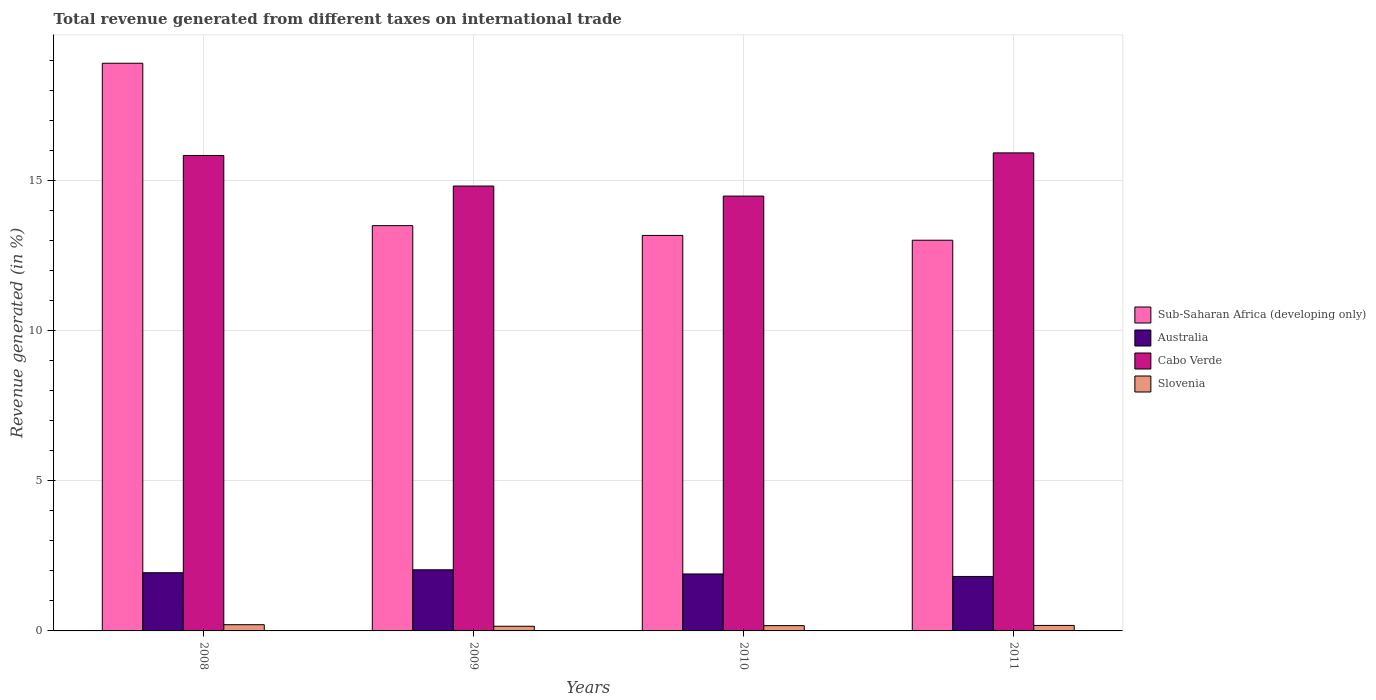Are the number of bars on each tick of the X-axis equal?
Your answer should be compact. Yes. How many bars are there on the 4th tick from the left?
Your answer should be very brief. 4. What is the label of the 4th group of bars from the left?
Ensure brevity in your answer.  2011. In how many cases, is the number of bars for a given year not equal to the number of legend labels?
Offer a very short reply. 0. What is the total revenue generated in Slovenia in 2008?
Offer a terse response. 0.21. Across all years, what is the maximum total revenue generated in Cabo Verde?
Your answer should be very brief. 15.92. Across all years, what is the minimum total revenue generated in Cabo Verde?
Offer a terse response. 14.48. In which year was the total revenue generated in Cabo Verde minimum?
Offer a terse response. 2010. What is the total total revenue generated in Sub-Saharan Africa (developing only) in the graph?
Make the answer very short. 58.58. What is the difference between the total revenue generated in Slovenia in 2009 and that in 2011?
Keep it short and to the point. -0.03. What is the difference between the total revenue generated in Cabo Verde in 2008 and the total revenue generated in Australia in 2010?
Offer a terse response. 13.94. What is the average total revenue generated in Slovenia per year?
Make the answer very short. 0.18. In the year 2011, what is the difference between the total revenue generated in Cabo Verde and total revenue generated in Australia?
Offer a terse response. 14.1. What is the ratio of the total revenue generated in Slovenia in 2010 to that in 2011?
Make the answer very short. 0.96. Is the difference between the total revenue generated in Cabo Verde in 2008 and 2009 greater than the difference between the total revenue generated in Australia in 2008 and 2009?
Provide a succinct answer. Yes. What is the difference between the highest and the second highest total revenue generated in Cabo Verde?
Keep it short and to the point. 0.09. What is the difference between the highest and the lowest total revenue generated in Australia?
Provide a succinct answer. 0.22. In how many years, is the total revenue generated in Slovenia greater than the average total revenue generated in Slovenia taken over all years?
Provide a succinct answer. 2. Is the sum of the total revenue generated in Sub-Saharan Africa (developing only) in 2009 and 2010 greater than the maximum total revenue generated in Australia across all years?
Offer a terse response. Yes. Is it the case that in every year, the sum of the total revenue generated in Sub-Saharan Africa (developing only) and total revenue generated in Cabo Verde is greater than the sum of total revenue generated in Australia and total revenue generated in Slovenia?
Offer a terse response. Yes. What does the 1st bar from the left in 2008 represents?
Offer a very short reply. Sub-Saharan Africa (developing only). What does the 1st bar from the right in 2009 represents?
Make the answer very short. Slovenia. Is it the case that in every year, the sum of the total revenue generated in Sub-Saharan Africa (developing only) and total revenue generated in Australia is greater than the total revenue generated in Cabo Verde?
Provide a succinct answer. No. How many bars are there?
Offer a terse response. 16. Are all the bars in the graph horizontal?
Provide a short and direct response. No. Does the graph contain any zero values?
Ensure brevity in your answer.  No. Does the graph contain grids?
Give a very brief answer. Yes. How many legend labels are there?
Offer a terse response. 4. What is the title of the graph?
Your answer should be compact. Total revenue generated from different taxes on international trade. Does "Upper middle income" appear as one of the legend labels in the graph?
Make the answer very short. No. What is the label or title of the Y-axis?
Make the answer very short. Revenue generated (in %). What is the Revenue generated (in %) in Sub-Saharan Africa (developing only) in 2008?
Make the answer very short. 18.9. What is the Revenue generated (in %) in Australia in 2008?
Keep it short and to the point. 1.94. What is the Revenue generated (in %) of Cabo Verde in 2008?
Provide a short and direct response. 15.83. What is the Revenue generated (in %) of Slovenia in 2008?
Your response must be concise. 0.21. What is the Revenue generated (in %) in Sub-Saharan Africa (developing only) in 2009?
Ensure brevity in your answer.  13.5. What is the Revenue generated (in %) of Australia in 2009?
Make the answer very short. 2.04. What is the Revenue generated (in %) in Cabo Verde in 2009?
Offer a terse response. 14.81. What is the Revenue generated (in %) of Slovenia in 2009?
Keep it short and to the point. 0.16. What is the Revenue generated (in %) in Sub-Saharan Africa (developing only) in 2010?
Keep it short and to the point. 13.17. What is the Revenue generated (in %) of Australia in 2010?
Offer a terse response. 1.9. What is the Revenue generated (in %) of Cabo Verde in 2010?
Ensure brevity in your answer.  14.48. What is the Revenue generated (in %) of Slovenia in 2010?
Offer a very short reply. 0.18. What is the Revenue generated (in %) in Sub-Saharan Africa (developing only) in 2011?
Offer a terse response. 13.01. What is the Revenue generated (in %) of Australia in 2011?
Your answer should be very brief. 1.81. What is the Revenue generated (in %) in Cabo Verde in 2011?
Make the answer very short. 15.92. What is the Revenue generated (in %) of Slovenia in 2011?
Your answer should be very brief. 0.18. Across all years, what is the maximum Revenue generated (in %) in Sub-Saharan Africa (developing only)?
Make the answer very short. 18.9. Across all years, what is the maximum Revenue generated (in %) in Australia?
Keep it short and to the point. 2.04. Across all years, what is the maximum Revenue generated (in %) in Cabo Verde?
Make the answer very short. 15.92. Across all years, what is the maximum Revenue generated (in %) in Slovenia?
Keep it short and to the point. 0.21. Across all years, what is the minimum Revenue generated (in %) in Sub-Saharan Africa (developing only)?
Your answer should be very brief. 13.01. Across all years, what is the minimum Revenue generated (in %) of Australia?
Provide a succinct answer. 1.81. Across all years, what is the minimum Revenue generated (in %) of Cabo Verde?
Give a very brief answer. 14.48. Across all years, what is the minimum Revenue generated (in %) in Slovenia?
Give a very brief answer. 0.16. What is the total Revenue generated (in %) in Sub-Saharan Africa (developing only) in the graph?
Keep it short and to the point. 58.58. What is the total Revenue generated (in %) in Australia in the graph?
Keep it short and to the point. 7.68. What is the total Revenue generated (in %) in Cabo Verde in the graph?
Make the answer very short. 61.05. What is the total Revenue generated (in %) in Slovenia in the graph?
Your answer should be compact. 0.72. What is the difference between the Revenue generated (in %) in Sub-Saharan Africa (developing only) in 2008 and that in 2009?
Keep it short and to the point. 5.41. What is the difference between the Revenue generated (in %) of Australia in 2008 and that in 2009?
Provide a short and direct response. -0.1. What is the difference between the Revenue generated (in %) in Cabo Verde in 2008 and that in 2009?
Your answer should be very brief. 1.02. What is the difference between the Revenue generated (in %) of Slovenia in 2008 and that in 2009?
Keep it short and to the point. 0.05. What is the difference between the Revenue generated (in %) in Sub-Saharan Africa (developing only) in 2008 and that in 2010?
Your answer should be compact. 5.73. What is the difference between the Revenue generated (in %) in Australia in 2008 and that in 2010?
Make the answer very short. 0.04. What is the difference between the Revenue generated (in %) of Cabo Verde in 2008 and that in 2010?
Give a very brief answer. 1.35. What is the difference between the Revenue generated (in %) of Slovenia in 2008 and that in 2010?
Your answer should be very brief. 0.03. What is the difference between the Revenue generated (in %) in Sub-Saharan Africa (developing only) in 2008 and that in 2011?
Keep it short and to the point. 5.89. What is the difference between the Revenue generated (in %) of Australia in 2008 and that in 2011?
Keep it short and to the point. 0.12. What is the difference between the Revenue generated (in %) of Cabo Verde in 2008 and that in 2011?
Provide a short and direct response. -0.09. What is the difference between the Revenue generated (in %) of Slovenia in 2008 and that in 2011?
Give a very brief answer. 0.02. What is the difference between the Revenue generated (in %) in Sub-Saharan Africa (developing only) in 2009 and that in 2010?
Your answer should be very brief. 0.33. What is the difference between the Revenue generated (in %) in Australia in 2009 and that in 2010?
Keep it short and to the point. 0.14. What is the difference between the Revenue generated (in %) of Cabo Verde in 2009 and that in 2010?
Make the answer very short. 0.33. What is the difference between the Revenue generated (in %) of Slovenia in 2009 and that in 2010?
Keep it short and to the point. -0.02. What is the difference between the Revenue generated (in %) of Sub-Saharan Africa (developing only) in 2009 and that in 2011?
Give a very brief answer. 0.49. What is the difference between the Revenue generated (in %) of Australia in 2009 and that in 2011?
Ensure brevity in your answer.  0.22. What is the difference between the Revenue generated (in %) in Cabo Verde in 2009 and that in 2011?
Ensure brevity in your answer.  -1.1. What is the difference between the Revenue generated (in %) in Slovenia in 2009 and that in 2011?
Offer a terse response. -0.03. What is the difference between the Revenue generated (in %) of Sub-Saharan Africa (developing only) in 2010 and that in 2011?
Keep it short and to the point. 0.16. What is the difference between the Revenue generated (in %) of Australia in 2010 and that in 2011?
Give a very brief answer. 0.08. What is the difference between the Revenue generated (in %) in Cabo Verde in 2010 and that in 2011?
Give a very brief answer. -1.44. What is the difference between the Revenue generated (in %) of Slovenia in 2010 and that in 2011?
Ensure brevity in your answer.  -0.01. What is the difference between the Revenue generated (in %) in Sub-Saharan Africa (developing only) in 2008 and the Revenue generated (in %) in Australia in 2009?
Provide a short and direct response. 16.87. What is the difference between the Revenue generated (in %) of Sub-Saharan Africa (developing only) in 2008 and the Revenue generated (in %) of Cabo Verde in 2009?
Make the answer very short. 4.09. What is the difference between the Revenue generated (in %) in Sub-Saharan Africa (developing only) in 2008 and the Revenue generated (in %) in Slovenia in 2009?
Keep it short and to the point. 18.75. What is the difference between the Revenue generated (in %) of Australia in 2008 and the Revenue generated (in %) of Cabo Verde in 2009?
Provide a short and direct response. -12.88. What is the difference between the Revenue generated (in %) in Australia in 2008 and the Revenue generated (in %) in Slovenia in 2009?
Your response must be concise. 1.78. What is the difference between the Revenue generated (in %) in Cabo Verde in 2008 and the Revenue generated (in %) in Slovenia in 2009?
Keep it short and to the point. 15.68. What is the difference between the Revenue generated (in %) in Sub-Saharan Africa (developing only) in 2008 and the Revenue generated (in %) in Australia in 2010?
Offer a very short reply. 17.01. What is the difference between the Revenue generated (in %) of Sub-Saharan Africa (developing only) in 2008 and the Revenue generated (in %) of Cabo Verde in 2010?
Keep it short and to the point. 4.42. What is the difference between the Revenue generated (in %) in Sub-Saharan Africa (developing only) in 2008 and the Revenue generated (in %) in Slovenia in 2010?
Provide a succinct answer. 18.73. What is the difference between the Revenue generated (in %) of Australia in 2008 and the Revenue generated (in %) of Cabo Verde in 2010?
Your answer should be very brief. -12.54. What is the difference between the Revenue generated (in %) in Australia in 2008 and the Revenue generated (in %) in Slovenia in 2010?
Provide a short and direct response. 1.76. What is the difference between the Revenue generated (in %) of Cabo Verde in 2008 and the Revenue generated (in %) of Slovenia in 2010?
Offer a very short reply. 15.66. What is the difference between the Revenue generated (in %) of Sub-Saharan Africa (developing only) in 2008 and the Revenue generated (in %) of Australia in 2011?
Provide a short and direct response. 17.09. What is the difference between the Revenue generated (in %) of Sub-Saharan Africa (developing only) in 2008 and the Revenue generated (in %) of Cabo Verde in 2011?
Your answer should be compact. 2.98. What is the difference between the Revenue generated (in %) of Sub-Saharan Africa (developing only) in 2008 and the Revenue generated (in %) of Slovenia in 2011?
Your response must be concise. 18.72. What is the difference between the Revenue generated (in %) in Australia in 2008 and the Revenue generated (in %) in Cabo Verde in 2011?
Ensure brevity in your answer.  -13.98. What is the difference between the Revenue generated (in %) of Australia in 2008 and the Revenue generated (in %) of Slovenia in 2011?
Offer a very short reply. 1.75. What is the difference between the Revenue generated (in %) of Cabo Verde in 2008 and the Revenue generated (in %) of Slovenia in 2011?
Your answer should be compact. 15.65. What is the difference between the Revenue generated (in %) in Sub-Saharan Africa (developing only) in 2009 and the Revenue generated (in %) in Australia in 2010?
Your response must be concise. 11.6. What is the difference between the Revenue generated (in %) of Sub-Saharan Africa (developing only) in 2009 and the Revenue generated (in %) of Cabo Verde in 2010?
Keep it short and to the point. -0.98. What is the difference between the Revenue generated (in %) of Sub-Saharan Africa (developing only) in 2009 and the Revenue generated (in %) of Slovenia in 2010?
Your answer should be very brief. 13.32. What is the difference between the Revenue generated (in %) in Australia in 2009 and the Revenue generated (in %) in Cabo Verde in 2010?
Keep it short and to the point. -12.44. What is the difference between the Revenue generated (in %) in Australia in 2009 and the Revenue generated (in %) in Slovenia in 2010?
Your answer should be very brief. 1.86. What is the difference between the Revenue generated (in %) in Cabo Verde in 2009 and the Revenue generated (in %) in Slovenia in 2010?
Your response must be concise. 14.64. What is the difference between the Revenue generated (in %) of Sub-Saharan Africa (developing only) in 2009 and the Revenue generated (in %) of Australia in 2011?
Provide a short and direct response. 11.68. What is the difference between the Revenue generated (in %) in Sub-Saharan Africa (developing only) in 2009 and the Revenue generated (in %) in Cabo Verde in 2011?
Your answer should be compact. -2.42. What is the difference between the Revenue generated (in %) in Sub-Saharan Africa (developing only) in 2009 and the Revenue generated (in %) in Slovenia in 2011?
Ensure brevity in your answer.  13.31. What is the difference between the Revenue generated (in %) of Australia in 2009 and the Revenue generated (in %) of Cabo Verde in 2011?
Offer a very short reply. -13.88. What is the difference between the Revenue generated (in %) of Australia in 2009 and the Revenue generated (in %) of Slovenia in 2011?
Provide a short and direct response. 1.85. What is the difference between the Revenue generated (in %) in Cabo Verde in 2009 and the Revenue generated (in %) in Slovenia in 2011?
Offer a terse response. 14.63. What is the difference between the Revenue generated (in %) in Sub-Saharan Africa (developing only) in 2010 and the Revenue generated (in %) in Australia in 2011?
Your answer should be very brief. 11.36. What is the difference between the Revenue generated (in %) of Sub-Saharan Africa (developing only) in 2010 and the Revenue generated (in %) of Cabo Verde in 2011?
Your answer should be very brief. -2.75. What is the difference between the Revenue generated (in %) of Sub-Saharan Africa (developing only) in 2010 and the Revenue generated (in %) of Slovenia in 2011?
Provide a succinct answer. 12.99. What is the difference between the Revenue generated (in %) in Australia in 2010 and the Revenue generated (in %) in Cabo Verde in 2011?
Provide a succinct answer. -14.02. What is the difference between the Revenue generated (in %) in Australia in 2010 and the Revenue generated (in %) in Slovenia in 2011?
Offer a very short reply. 1.71. What is the difference between the Revenue generated (in %) in Cabo Verde in 2010 and the Revenue generated (in %) in Slovenia in 2011?
Ensure brevity in your answer.  14.3. What is the average Revenue generated (in %) of Sub-Saharan Africa (developing only) per year?
Offer a terse response. 14.64. What is the average Revenue generated (in %) of Australia per year?
Ensure brevity in your answer.  1.92. What is the average Revenue generated (in %) in Cabo Verde per year?
Provide a succinct answer. 15.26. What is the average Revenue generated (in %) in Slovenia per year?
Your response must be concise. 0.18. In the year 2008, what is the difference between the Revenue generated (in %) in Sub-Saharan Africa (developing only) and Revenue generated (in %) in Australia?
Offer a very short reply. 16.97. In the year 2008, what is the difference between the Revenue generated (in %) of Sub-Saharan Africa (developing only) and Revenue generated (in %) of Cabo Verde?
Give a very brief answer. 3.07. In the year 2008, what is the difference between the Revenue generated (in %) of Sub-Saharan Africa (developing only) and Revenue generated (in %) of Slovenia?
Provide a succinct answer. 18.7. In the year 2008, what is the difference between the Revenue generated (in %) in Australia and Revenue generated (in %) in Cabo Verde?
Keep it short and to the point. -13.89. In the year 2008, what is the difference between the Revenue generated (in %) in Australia and Revenue generated (in %) in Slovenia?
Your answer should be compact. 1.73. In the year 2008, what is the difference between the Revenue generated (in %) of Cabo Verde and Revenue generated (in %) of Slovenia?
Offer a terse response. 15.63. In the year 2009, what is the difference between the Revenue generated (in %) of Sub-Saharan Africa (developing only) and Revenue generated (in %) of Australia?
Ensure brevity in your answer.  11.46. In the year 2009, what is the difference between the Revenue generated (in %) in Sub-Saharan Africa (developing only) and Revenue generated (in %) in Cabo Verde?
Offer a very short reply. -1.32. In the year 2009, what is the difference between the Revenue generated (in %) of Sub-Saharan Africa (developing only) and Revenue generated (in %) of Slovenia?
Keep it short and to the point. 13.34. In the year 2009, what is the difference between the Revenue generated (in %) of Australia and Revenue generated (in %) of Cabo Verde?
Your response must be concise. -12.78. In the year 2009, what is the difference between the Revenue generated (in %) in Australia and Revenue generated (in %) in Slovenia?
Make the answer very short. 1.88. In the year 2009, what is the difference between the Revenue generated (in %) of Cabo Verde and Revenue generated (in %) of Slovenia?
Offer a terse response. 14.66. In the year 2010, what is the difference between the Revenue generated (in %) of Sub-Saharan Africa (developing only) and Revenue generated (in %) of Australia?
Your answer should be compact. 11.27. In the year 2010, what is the difference between the Revenue generated (in %) of Sub-Saharan Africa (developing only) and Revenue generated (in %) of Cabo Verde?
Make the answer very short. -1.31. In the year 2010, what is the difference between the Revenue generated (in %) of Sub-Saharan Africa (developing only) and Revenue generated (in %) of Slovenia?
Your answer should be compact. 12.99. In the year 2010, what is the difference between the Revenue generated (in %) of Australia and Revenue generated (in %) of Cabo Verde?
Ensure brevity in your answer.  -12.58. In the year 2010, what is the difference between the Revenue generated (in %) of Australia and Revenue generated (in %) of Slovenia?
Give a very brief answer. 1.72. In the year 2010, what is the difference between the Revenue generated (in %) in Cabo Verde and Revenue generated (in %) in Slovenia?
Make the answer very short. 14.3. In the year 2011, what is the difference between the Revenue generated (in %) of Sub-Saharan Africa (developing only) and Revenue generated (in %) of Australia?
Provide a short and direct response. 11.2. In the year 2011, what is the difference between the Revenue generated (in %) in Sub-Saharan Africa (developing only) and Revenue generated (in %) in Cabo Verde?
Provide a succinct answer. -2.91. In the year 2011, what is the difference between the Revenue generated (in %) of Sub-Saharan Africa (developing only) and Revenue generated (in %) of Slovenia?
Your answer should be compact. 12.83. In the year 2011, what is the difference between the Revenue generated (in %) of Australia and Revenue generated (in %) of Cabo Verde?
Keep it short and to the point. -14.1. In the year 2011, what is the difference between the Revenue generated (in %) of Australia and Revenue generated (in %) of Slovenia?
Ensure brevity in your answer.  1.63. In the year 2011, what is the difference between the Revenue generated (in %) of Cabo Verde and Revenue generated (in %) of Slovenia?
Your response must be concise. 15.74. What is the ratio of the Revenue generated (in %) of Sub-Saharan Africa (developing only) in 2008 to that in 2009?
Give a very brief answer. 1.4. What is the ratio of the Revenue generated (in %) of Australia in 2008 to that in 2009?
Your answer should be compact. 0.95. What is the ratio of the Revenue generated (in %) of Cabo Verde in 2008 to that in 2009?
Make the answer very short. 1.07. What is the ratio of the Revenue generated (in %) of Slovenia in 2008 to that in 2009?
Keep it short and to the point. 1.33. What is the ratio of the Revenue generated (in %) of Sub-Saharan Africa (developing only) in 2008 to that in 2010?
Your answer should be compact. 1.44. What is the ratio of the Revenue generated (in %) of Australia in 2008 to that in 2010?
Your answer should be compact. 1.02. What is the ratio of the Revenue generated (in %) of Cabo Verde in 2008 to that in 2010?
Your answer should be very brief. 1.09. What is the ratio of the Revenue generated (in %) of Slovenia in 2008 to that in 2010?
Give a very brief answer. 1.18. What is the ratio of the Revenue generated (in %) in Sub-Saharan Africa (developing only) in 2008 to that in 2011?
Your response must be concise. 1.45. What is the ratio of the Revenue generated (in %) of Australia in 2008 to that in 2011?
Your answer should be compact. 1.07. What is the ratio of the Revenue generated (in %) of Slovenia in 2008 to that in 2011?
Make the answer very short. 1.13. What is the ratio of the Revenue generated (in %) in Sub-Saharan Africa (developing only) in 2009 to that in 2010?
Keep it short and to the point. 1.02. What is the ratio of the Revenue generated (in %) of Australia in 2009 to that in 2010?
Provide a short and direct response. 1.07. What is the ratio of the Revenue generated (in %) of Cabo Verde in 2009 to that in 2010?
Give a very brief answer. 1.02. What is the ratio of the Revenue generated (in %) in Slovenia in 2009 to that in 2010?
Offer a terse response. 0.89. What is the ratio of the Revenue generated (in %) in Sub-Saharan Africa (developing only) in 2009 to that in 2011?
Your answer should be very brief. 1.04. What is the ratio of the Revenue generated (in %) in Australia in 2009 to that in 2011?
Keep it short and to the point. 1.12. What is the ratio of the Revenue generated (in %) in Cabo Verde in 2009 to that in 2011?
Provide a succinct answer. 0.93. What is the ratio of the Revenue generated (in %) in Slovenia in 2009 to that in 2011?
Give a very brief answer. 0.85. What is the ratio of the Revenue generated (in %) in Sub-Saharan Africa (developing only) in 2010 to that in 2011?
Your response must be concise. 1.01. What is the ratio of the Revenue generated (in %) of Australia in 2010 to that in 2011?
Give a very brief answer. 1.05. What is the ratio of the Revenue generated (in %) in Cabo Verde in 2010 to that in 2011?
Your answer should be very brief. 0.91. What is the ratio of the Revenue generated (in %) of Slovenia in 2010 to that in 2011?
Provide a short and direct response. 0.96. What is the difference between the highest and the second highest Revenue generated (in %) of Sub-Saharan Africa (developing only)?
Make the answer very short. 5.41. What is the difference between the highest and the second highest Revenue generated (in %) in Australia?
Your response must be concise. 0.1. What is the difference between the highest and the second highest Revenue generated (in %) of Cabo Verde?
Make the answer very short. 0.09. What is the difference between the highest and the second highest Revenue generated (in %) of Slovenia?
Make the answer very short. 0.02. What is the difference between the highest and the lowest Revenue generated (in %) in Sub-Saharan Africa (developing only)?
Your answer should be compact. 5.89. What is the difference between the highest and the lowest Revenue generated (in %) of Australia?
Ensure brevity in your answer.  0.22. What is the difference between the highest and the lowest Revenue generated (in %) of Cabo Verde?
Your response must be concise. 1.44. What is the difference between the highest and the lowest Revenue generated (in %) in Slovenia?
Your answer should be compact. 0.05. 